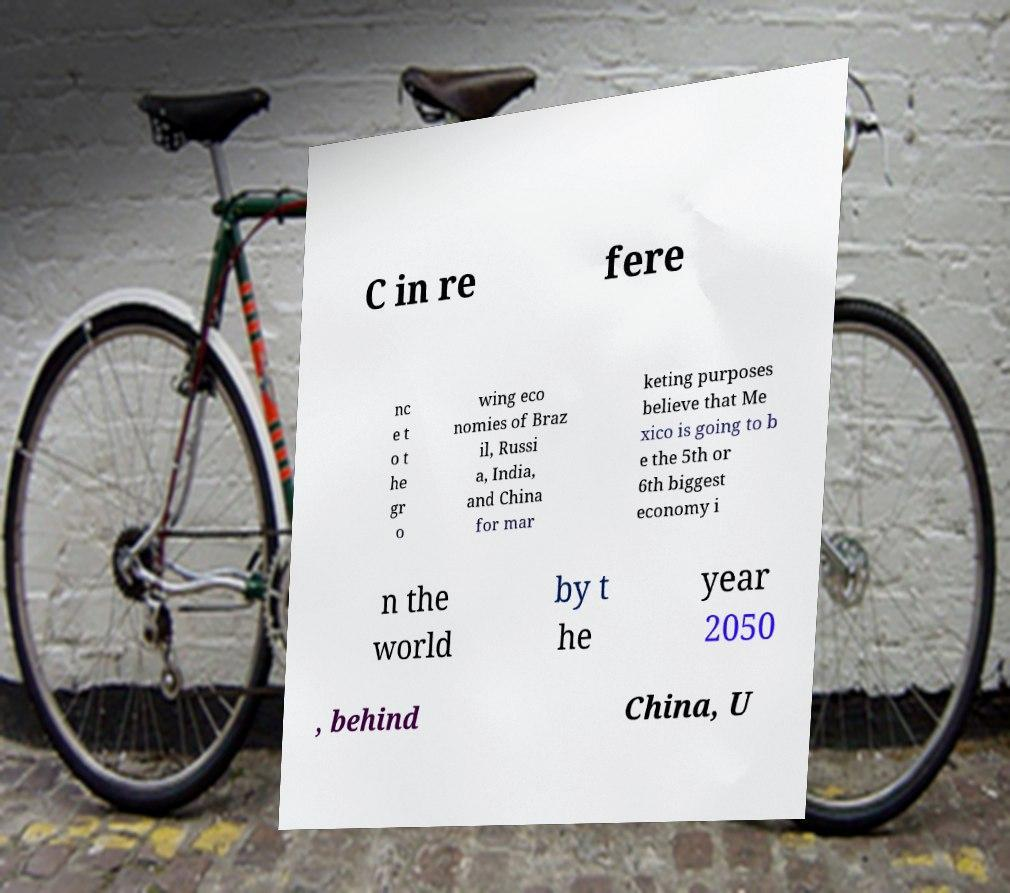There's text embedded in this image that I need extracted. Can you transcribe it verbatim? C in re fere nc e t o t he gr o wing eco nomies of Braz il, Russi a, India, and China for mar keting purposes believe that Me xico is going to b e the 5th or 6th biggest economy i n the world by t he year 2050 , behind China, U 